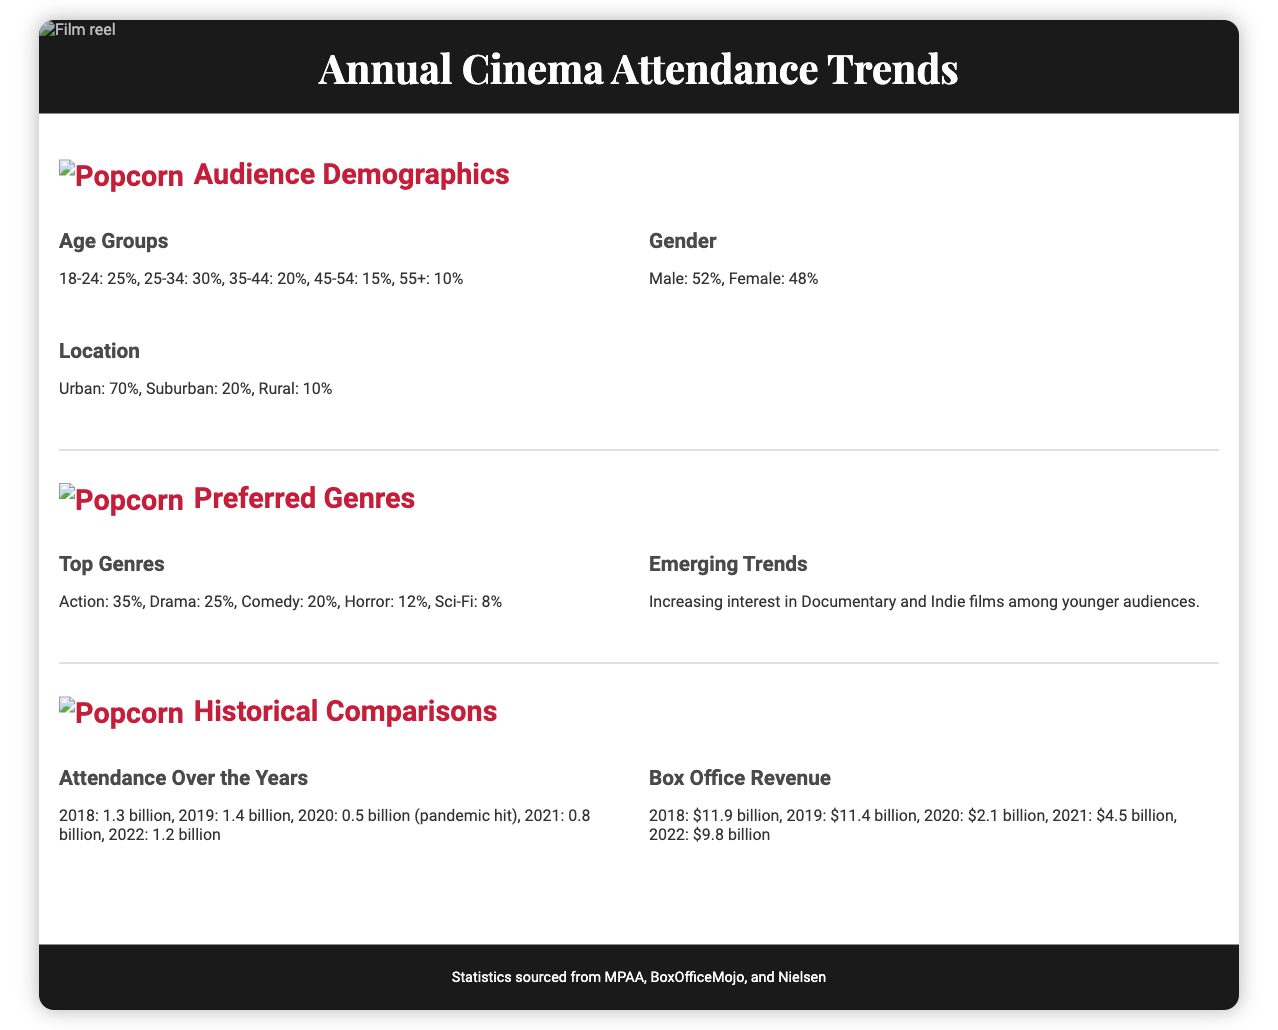What percentage of cinema attendees are aged 18-24? The document states that 25% of attendees belong to the 18-24 age group.
Answer: 25% What is the gender distribution of the audience? The document provides the gender distribution as Male: 52%, Female: 48%.
Answer: Male: 52%, Female: 48% Which genre has the highest attendance percentage? According to the document, the Action genre has the highest attendance percentage at 35%.
Answer: Action: 35% What was the cinema attendance in 2020? The document mentions that cinema attendance in 2020 dropped to 0.5 billion due to the pandemic.
Answer: 0.5 billion What trend is emerging among younger audiences? The document notes an increasing interest in Documentary and Indie films among younger audiences.
Answer: Documentary and Indie films What percent of the audience is located in urban areas? The document states that 70% of the audience is located in urban areas.
Answer: 70% What was the box office revenue in 2019? The box office revenue in 2019 was $11.4 billion, as stated in the document.
Answer: $11.4 billion What is the total attendance increase from 2021 to 2022? The increase in attendance from 2021 (0.8 billion) to 2022 (1.2 billion) is 0.4 billion.
Answer: 0.4 billion What demographic section includes age groups? The age groups are included in the Audience Demographics section of the document.
Answer: Audience Demographics 